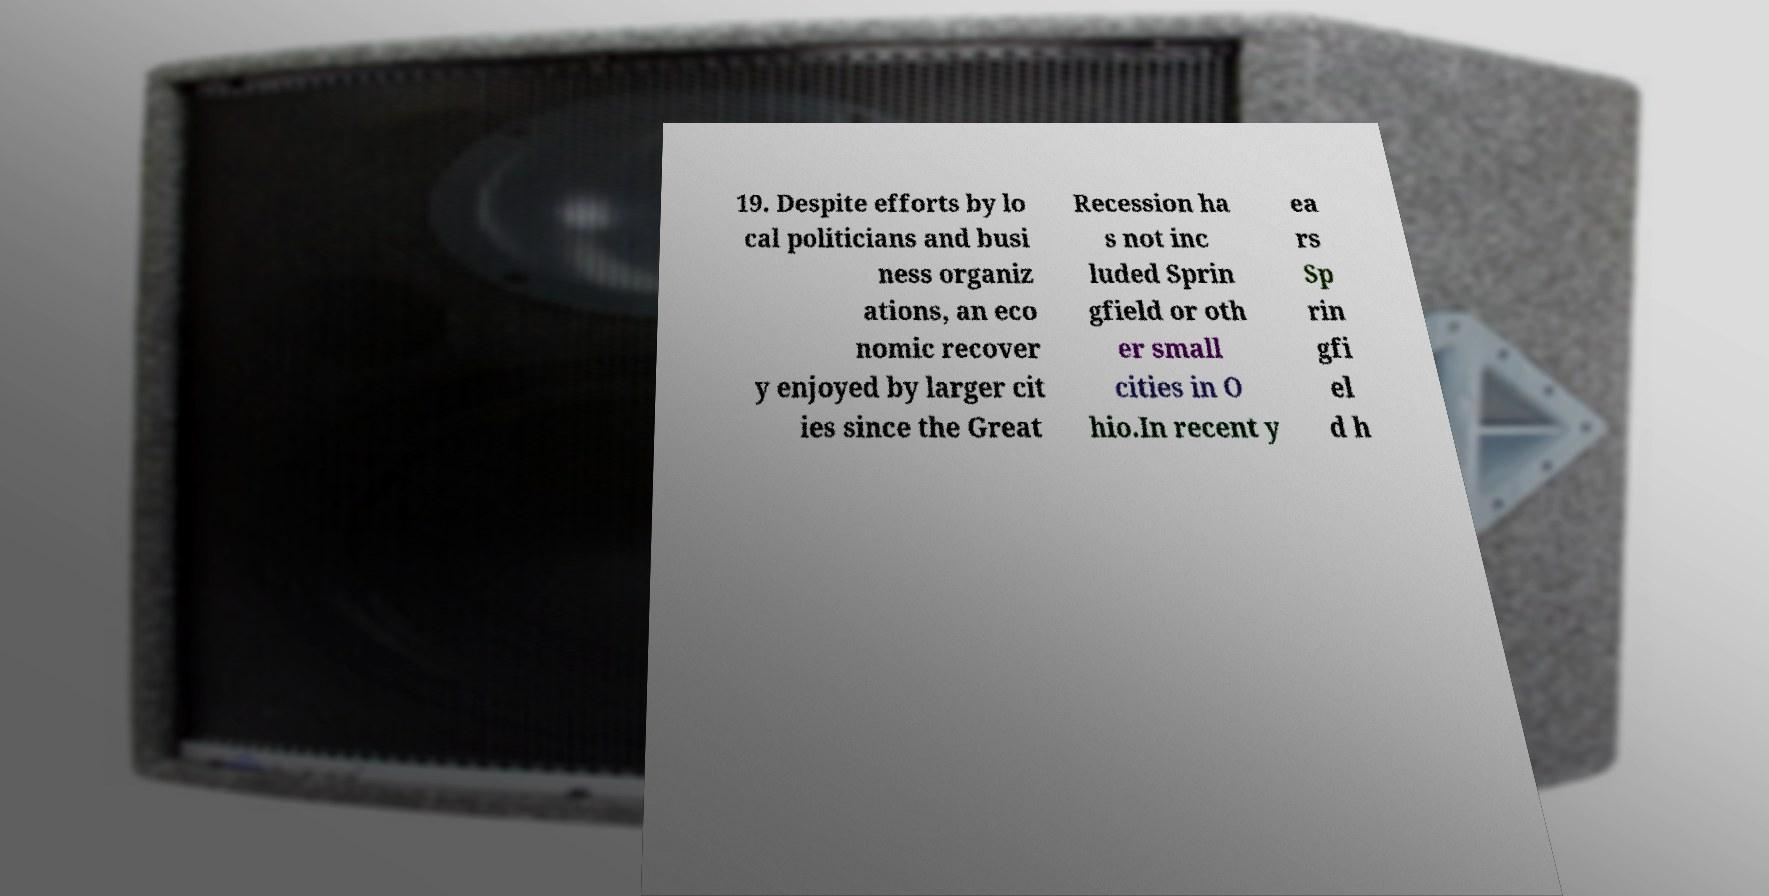Please read and relay the text visible in this image. What does it say? 19. Despite efforts by lo cal politicians and busi ness organiz ations, an eco nomic recover y enjoyed by larger cit ies since the Great Recession ha s not inc luded Sprin gfield or oth er small cities in O hio.In recent y ea rs Sp rin gfi el d h 